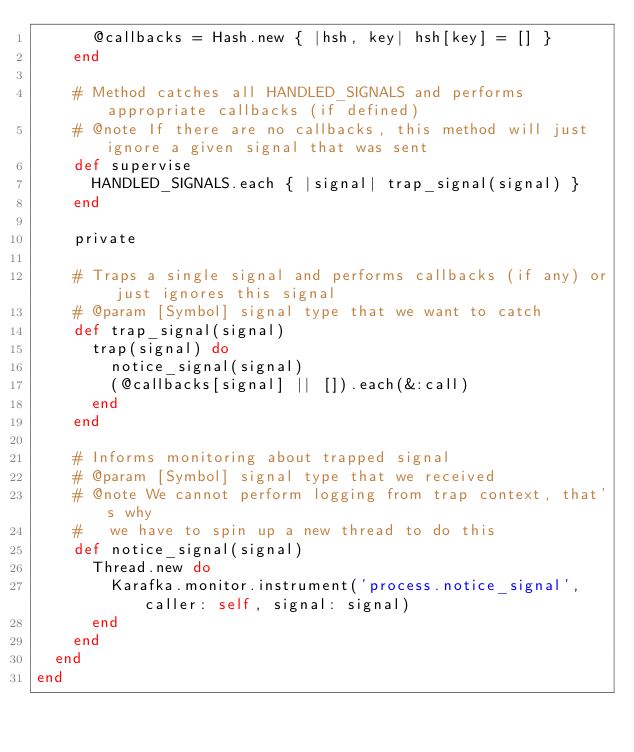<code> <loc_0><loc_0><loc_500><loc_500><_Ruby_>      @callbacks = Hash.new { |hsh, key| hsh[key] = [] }
    end

    # Method catches all HANDLED_SIGNALS and performs appropriate callbacks (if defined)
    # @note If there are no callbacks, this method will just ignore a given signal that was sent
    def supervise
      HANDLED_SIGNALS.each { |signal| trap_signal(signal) }
    end

    private

    # Traps a single signal and performs callbacks (if any) or just ignores this signal
    # @param [Symbol] signal type that we want to catch
    def trap_signal(signal)
      trap(signal) do
        notice_signal(signal)
        (@callbacks[signal] || []).each(&:call)
      end
    end

    # Informs monitoring about trapped signal
    # @param [Symbol] signal type that we received
    # @note We cannot perform logging from trap context, that's why
    #   we have to spin up a new thread to do this
    def notice_signal(signal)
      Thread.new do
        Karafka.monitor.instrument('process.notice_signal', caller: self, signal: signal)
      end
    end
  end
end
</code> 